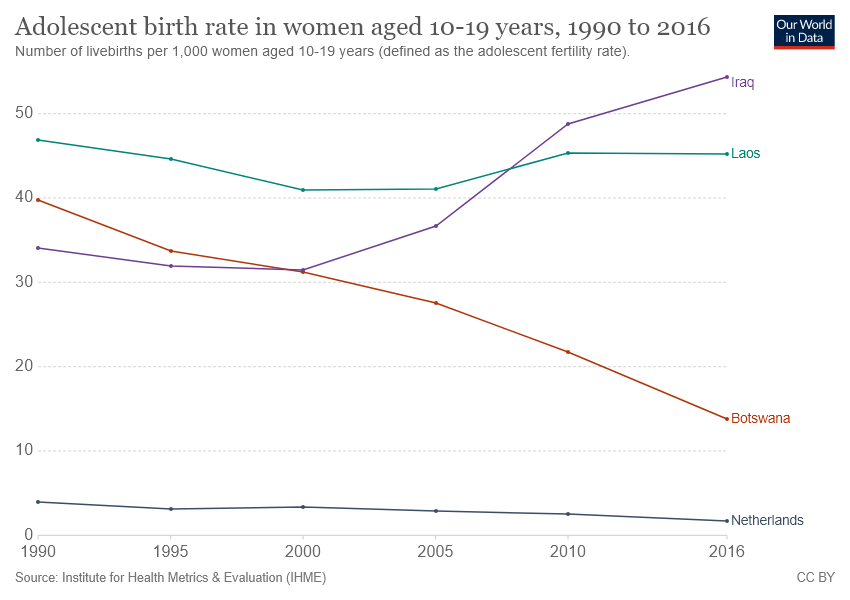Outline some significant characteristics in this image. Laos has a higher adolescent birth rate in women than Botswana. Iraq had the highest adolescent birth rate among women aged 10-19 years over the given years. 